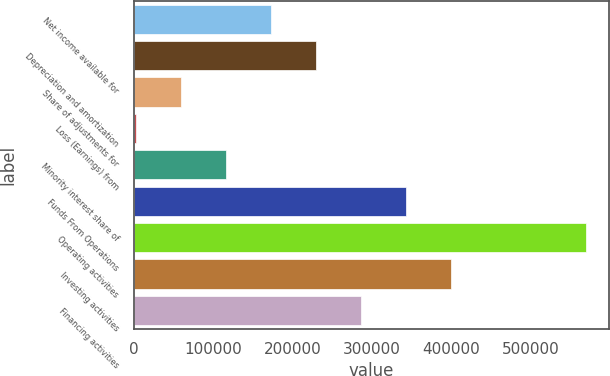Convert chart. <chart><loc_0><loc_0><loc_500><loc_500><bar_chart><fcel>Net income available for<fcel>Depreciation and amortization<fcel>Share of adjustments for<fcel>Loss (Earnings) from<fcel>Minority interest share of<fcel>Funds From Operations<fcel>Operating activities<fcel>Investing activities<fcel>Financing activities<nl><fcel>173280<fcel>229896<fcel>60046.6<fcel>3430<fcel>116663<fcel>343130<fcel>569596<fcel>399746<fcel>286513<nl></chart> 